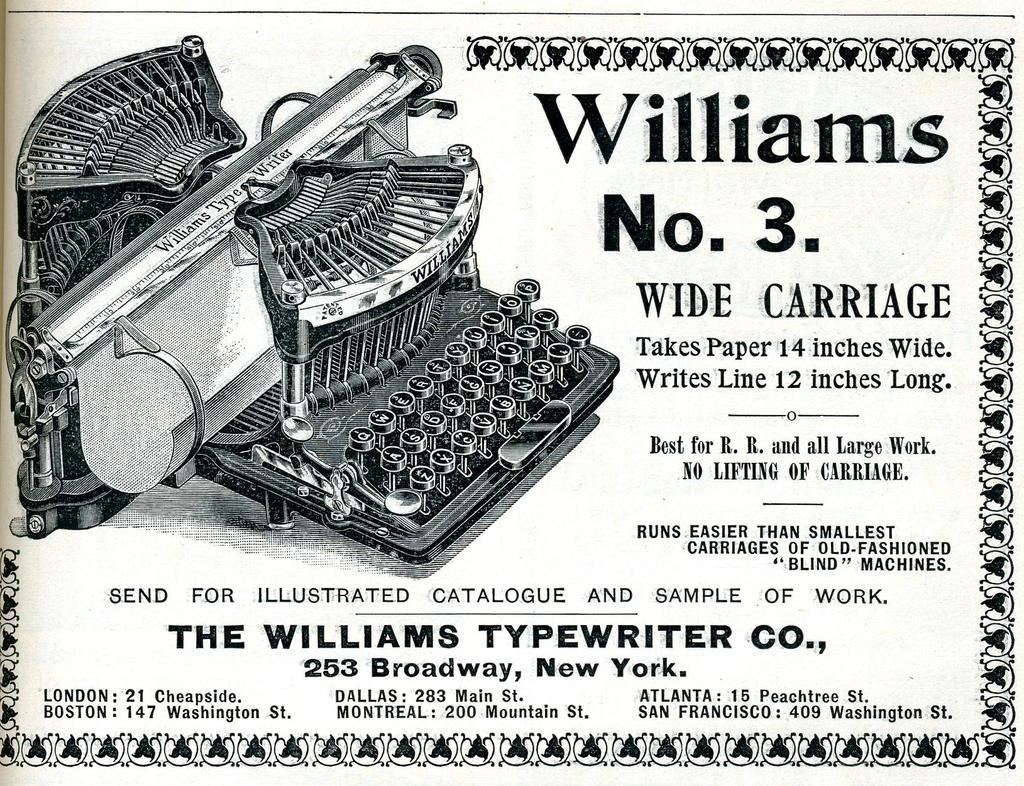<image>
Provide a brief description of the given image. A advertisment for a Williams NO. 3 typewriter. 